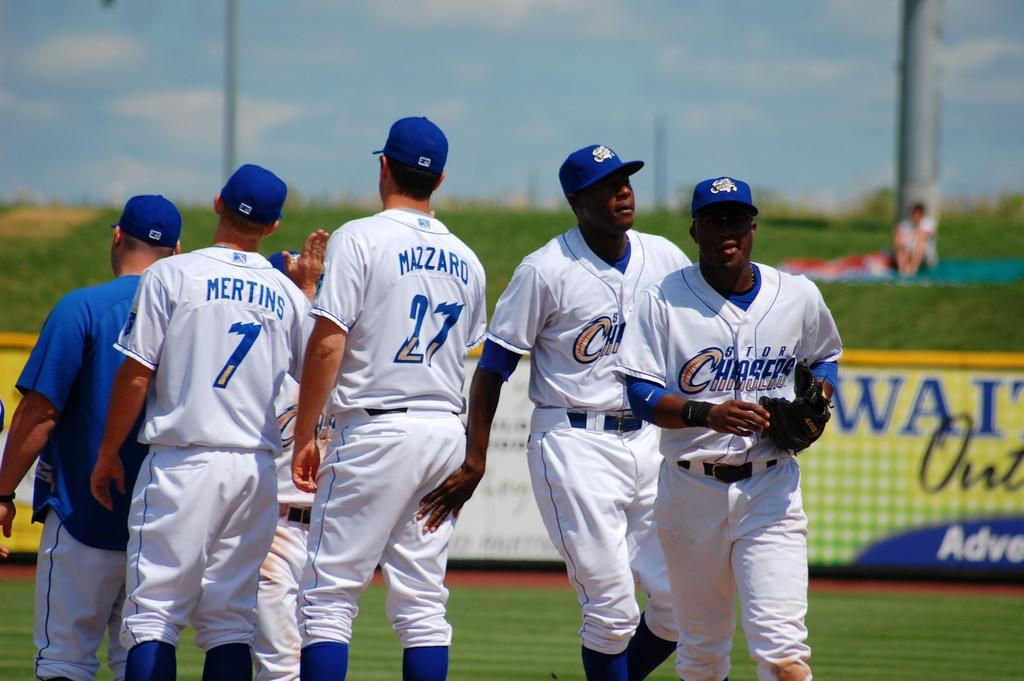<image>
Write a terse but informative summary of the picture. The Storm Chasers team are giving praise after a game 